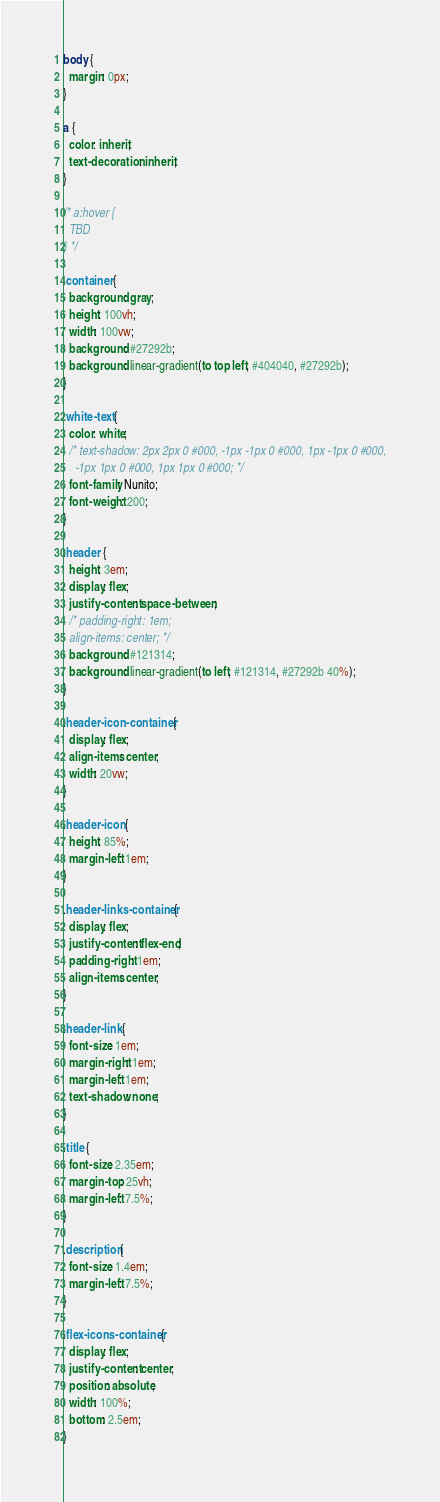Convert code to text. <code><loc_0><loc_0><loc_500><loc_500><_CSS_>body {
  margin: 0px;
}

a {
  color: inherit;
  text-decoration: inherit;
}

/* a:hover {
  TBD
} */

.container {
  background: gray;
  height: 100vh;
  width: 100vw;
  background: #27292b;
  background: linear-gradient(to top left, #404040, #27292b);
}

.white-text {
  color: white;
  /* text-shadow: 2px 2px 0 #000, -1px -1px 0 #000, 1px -1px 0 #000,
    -1px 1px 0 #000, 1px 1px 0 #000; */
  font-family: Nunito;
  font-weight: 200;
}

.header {
  height: 3em;
  display: flex;
  justify-content: space-between;
  /* padding-right: 1em;
  align-items: center; */
  background: #121314;
  background: linear-gradient(to left, #121314, #27292b 40%);
}

.header-icon-container {
  display: flex;
  align-items: center;
  width: 20vw;
}

.header-icon {
  height: 85%;
  margin-left: 1em;
}

.header-links-container {
  display: flex;
  justify-content: flex-end;
  padding-right: 1em;
  align-items: center;
}

.header-link {
  font-size: 1em;
  margin-right: 1em;
  margin-left: 1em;
  text-shadow: none;
}

.title {
  font-size: 2.35em;
  margin-top: 25vh;
  margin-left: 7.5%;
}

.description {
  font-size: 1.4em;
  margin-left: 7.5%;
}

.flex-icons-container {
  display: flex;
  justify-content: center;
  position: absolute;
  width: 100%;
  bottom: 2.5em;
}
</code> 